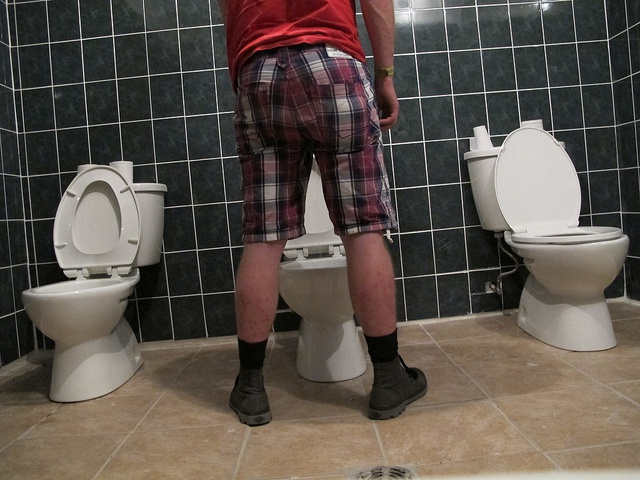Describe the objects in this image and their specific colors. I can see people in black, maroon, gray, and brown tones, toilet in black, lightgray, gray, and darkgray tones, toilet in black, darkgray, and gray tones, and toilet in black, gray, and darkgray tones in this image. 